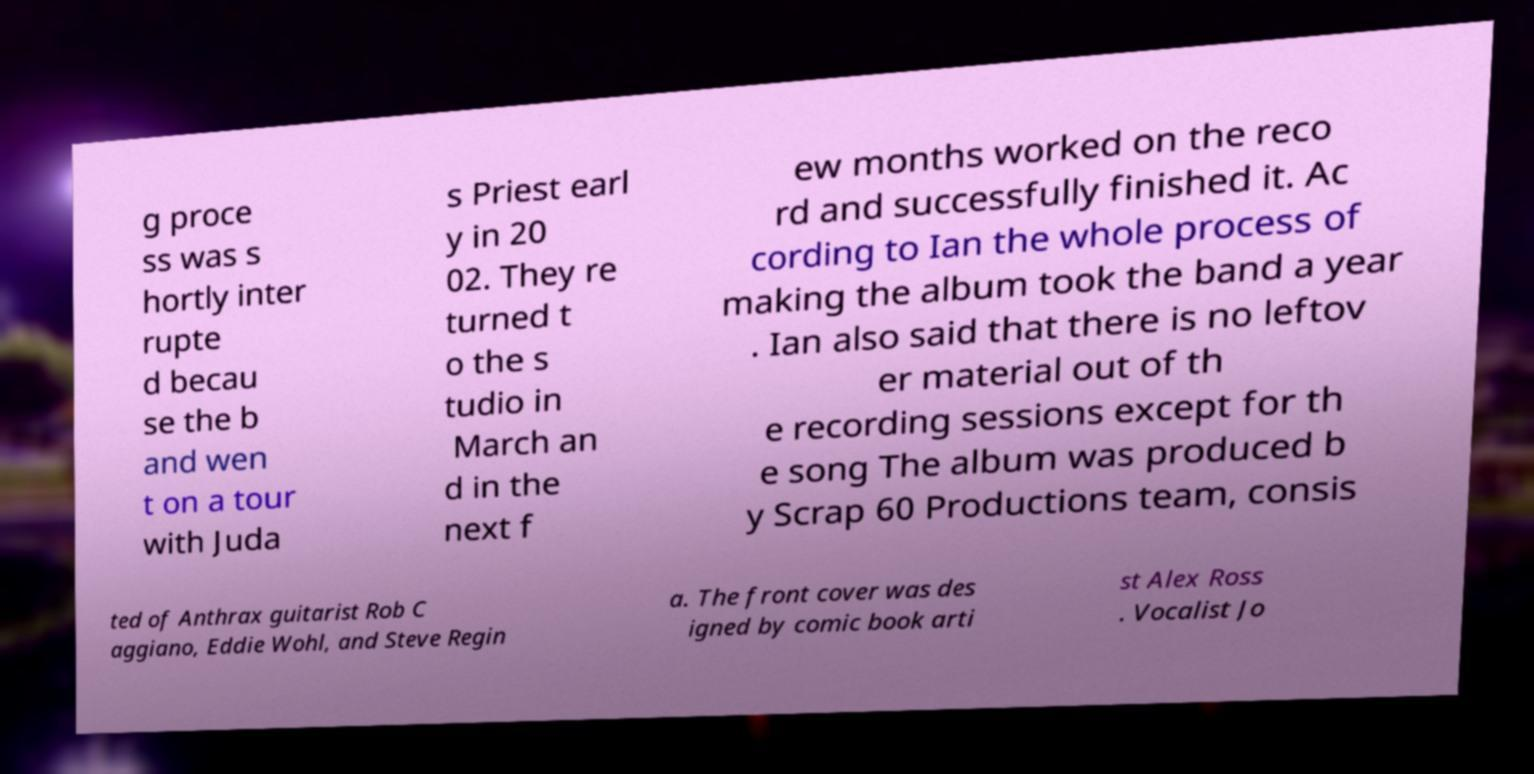Please identify and transcribe the text found in this image. g proce ss was s hortly inter rupte d becau se the b and wen t on a tour with Juda s Priest earl y in 20 02. They re turned t o the s tudio in March an d in the next f ew months worked on the reco rd and successfully finished it. Ac cording to Ian the whole process of making the album took the band a year . Ian also said that there is no leftov er material out of th e recording sessions except for th e song The album was produced b y Scrap 60 Productions team, consis ted of Anthrax guitarist Rob C aggiano, Eddie Wohl, and Steve Regin a. The front cover was des igned by comic book arti st Alex Ross . Vocalist Jo 